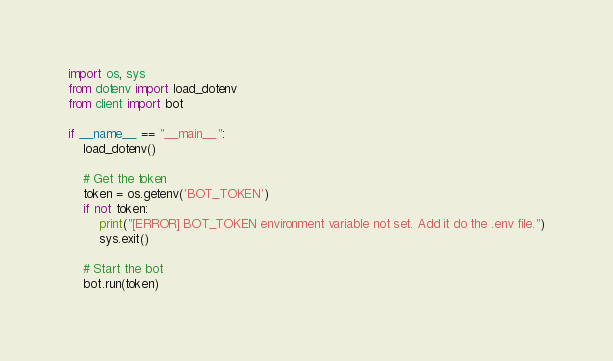Convert code to text. <code><loc_0><loc_0><loc_500><loc_500><_Python_>import os, sys
from dotenv import load_dotenv
from client import bot

if __name__ == "__main__":
    load_dotenv()

    # Get the token
    token = os.getenv('BOT_TOKEN')
    if not token:
        print("[ERROR] BOT_TOKEN environment variable not set. Add it do the .env file.")
        sys.exit()

    # Start the bot
    bot.run(token)
</code> 